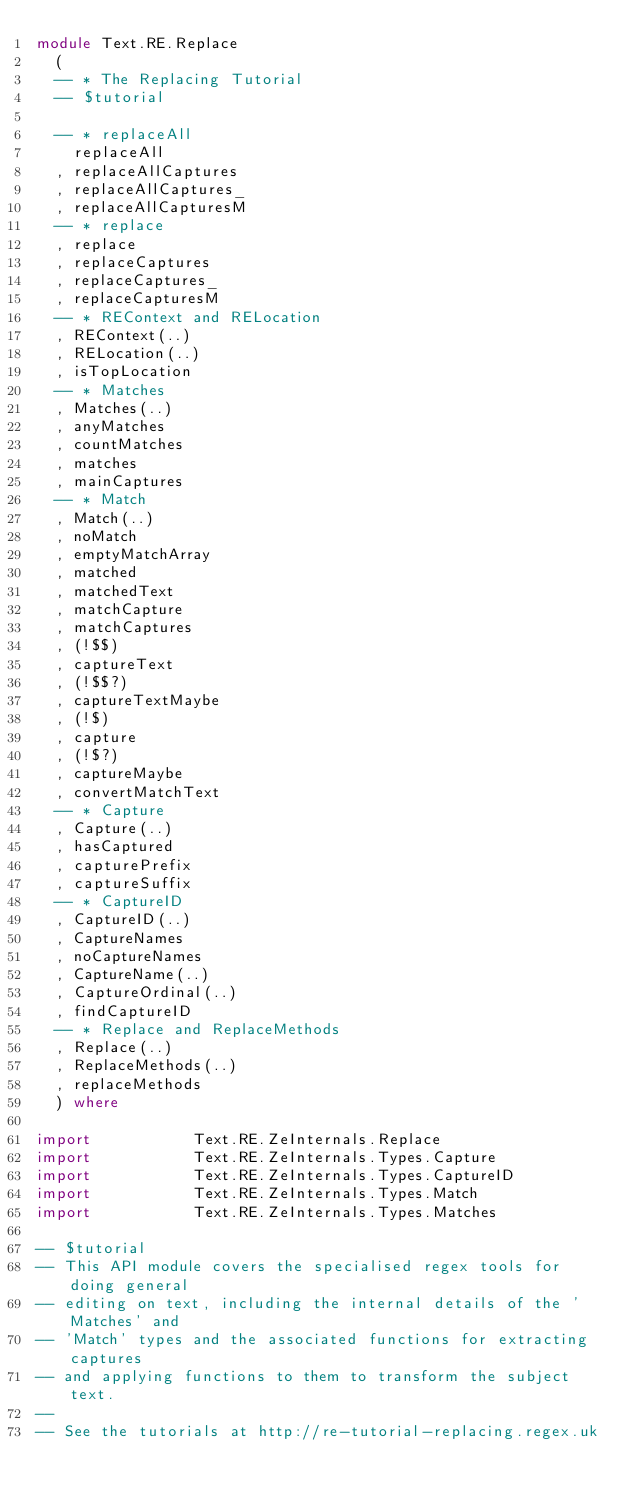Convert code to text. <code><loc_0><loc_0><loc_500><loc_500><_Haskell_>module Text.RE.Replace
  (
  -- * The Replacing Tutorial
  -- $tutorial

  -- * replaceAll
    replaceAll
  , replaceAllCaptures
  , replaceAllCaptures_
  , replaceAllCapturesM
  -- * replace
  , replace
  , replaceCaptures
  , replaceCaptures_
  , replaceCapturesM
  -- * REContext and RELocation
  , REContext(..)
  , RELocation(..)
  , isTopLocation
  -- * Matches
  , Matches(..)
  , anyMatches
  , countMatches
  , matches
  , mainCaptures
  -- * Match
  , Match(..)
  , noMatch
  , emptyMatchArray
  , matched
  , matchedText
  , matchCapture
  , matchCaptures
  , (!$$)
  , captureText
  , (!$$?)
  , captureTextMaybe
  , (!$)
  , capture
  , (!$?)
  , captureMaybe
  , convertMatchText
  -- * Capture
  , Capture(..)
  , hasCaptured
  , capturePrefix
  , captureSuffix
  -- * CaptureID
  , CaptureID(..)
  , CaptureNames
  , noCaptureNames
  , CaptureName(..)
  , CaptureOrdinal(..)
  , findCaptureID
  -- * Replace and ReplaceMethods
  , Replace(..)
  , ReplaceMethods(..)
  , replaceMethods
  ) where

import           Text.RE.ZeInternals.Replace
import           Text.RE.ZeInternals.Types.Capture
import           Text.RE.ZeInternals.Types.CaptureID
import           Text.RE.ZeInternals.Types.Match
import           Text.RE.ZeInternals.Types.Matches

-- $tutorial
-- This API module covers the specialised regex tools for doing general
-- editing on text, including the internal details of the 'Matches' and
-- 'Match' types and the associated functions for extracting captures
-- and applying functions to them to transform the subject text.
--
-- See the tutorials at http://re-tutorial-replacing.regex.uk
</code> 